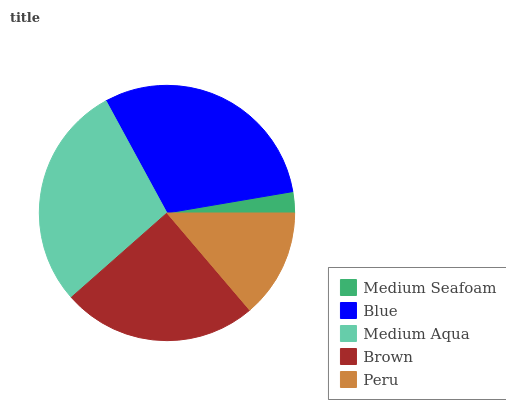Is Medium Seafoam the minimum?
Answer yes or no. Yes. Is Blue the maximum?
Answer yes or no. Yes. Is Medium Aqua the minimum?
Answer yes or no. No. Is Medium Aqua the maximum?
Answer yes or no. No. Is Blue greater than Medium Aqua?
Answer yes or no. Yes. Is Medium Aqua less than Blue?
Answer yes or no. Yes. Is Medium Aqua greater than Blue?
Answer yes or no. No. Is Blue less than Medium Aqua?
Answer yes or no. No. Is Brown the high median?
Answer yes or no. Yes. Is Brown the low median?
Answer yes or no. Yes. Is Blue the high median?
Answer yes or no. No. Is Medium Aqua the low median?
Answer yes or no. No. 